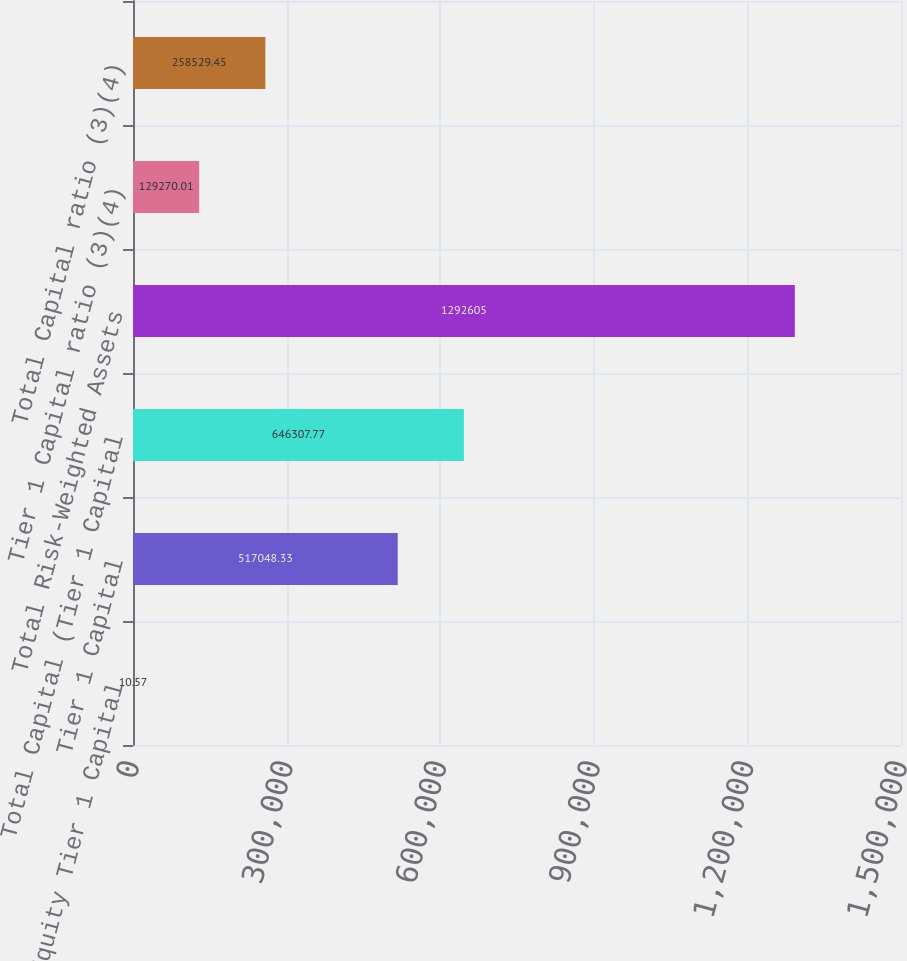<chart> <loc_0><loc_0><loc_500><loc_500><bar_chart><fcel>Common Equity Tier 1 Capital<fcel>Tier 1 Capital<fcel>Total Capital (Tier 1 Capital<fcel>Total Risk-Weighted Assets<fcel>Tier 1 Capital ratio (3)(4)<fcel>Total Capital ratio (3)(4)<nl><fcel>10.57<fcel>517048<fcel>646308<fcel>1.2926e+06<fcel>129270<fcel>258529<nl></chart> 